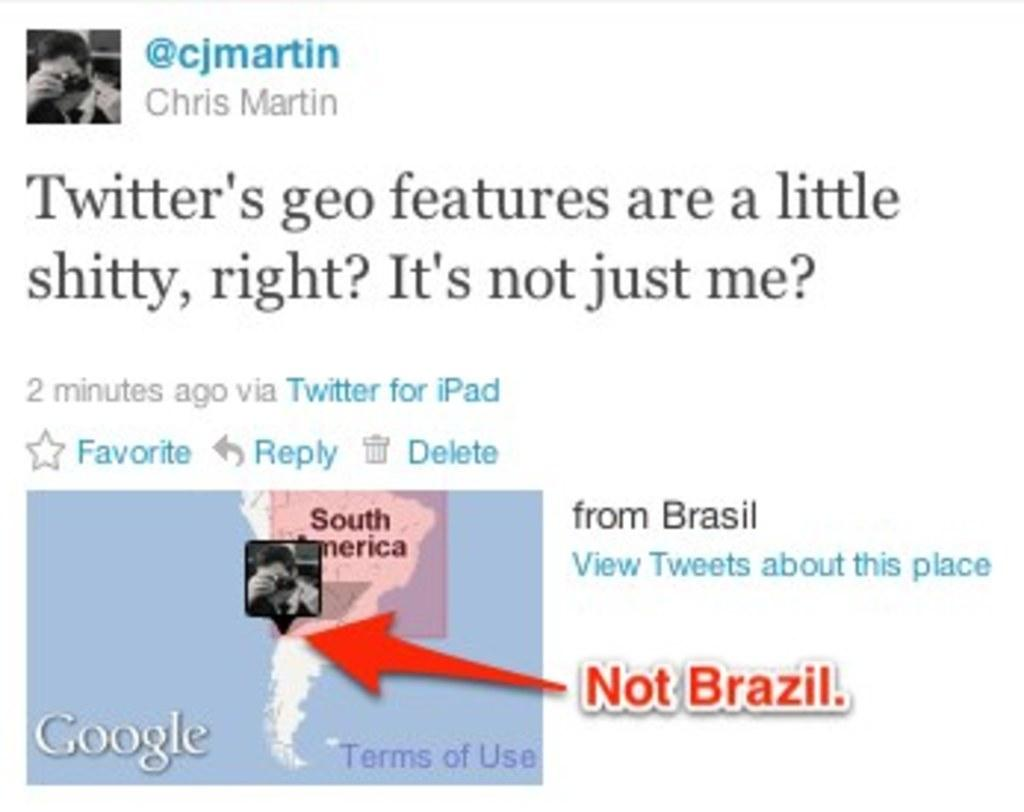What type of visual content is featured on the poster in the image? There is a poster with text in the image. What other types of visual content can be seen in the image? There are photographs and a map present in the image. What type of joke is depicted in the map in the image? There is no joke present in the image, as it features a map and other visual content. How does the brain interact with the poster in the image? There is no brain present in the image, so it cannot interact with the poster or any other visual content. 